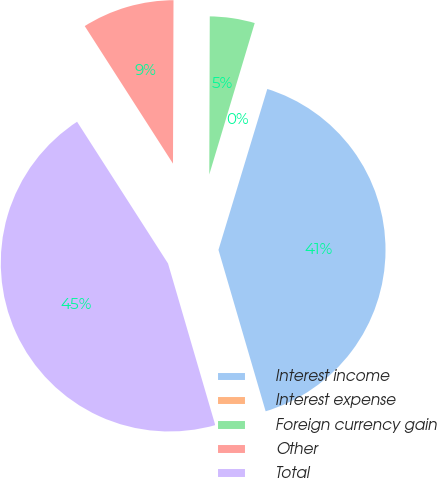<chart> <loc_0><loc_0><loc_500><loc_500><pie_chart><fcel>Interest income<fcel>Interest expense<fcel>Foreign currency gain<fcel>Other<fcel>Total<nl><fcel>40.79%<fcel>0.05%<fcel>4.59%<fcel>9.13%<fcel>45.45%<nl></chart> 